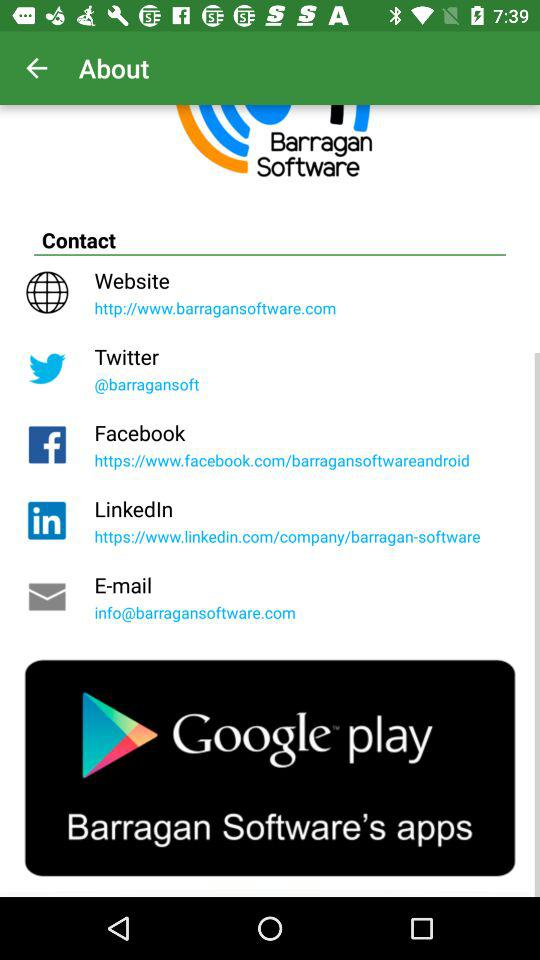Which are the different options to contact? The different options are "Website", "Twitter", "Facebook", "LinkedIn" and "E-mail". 